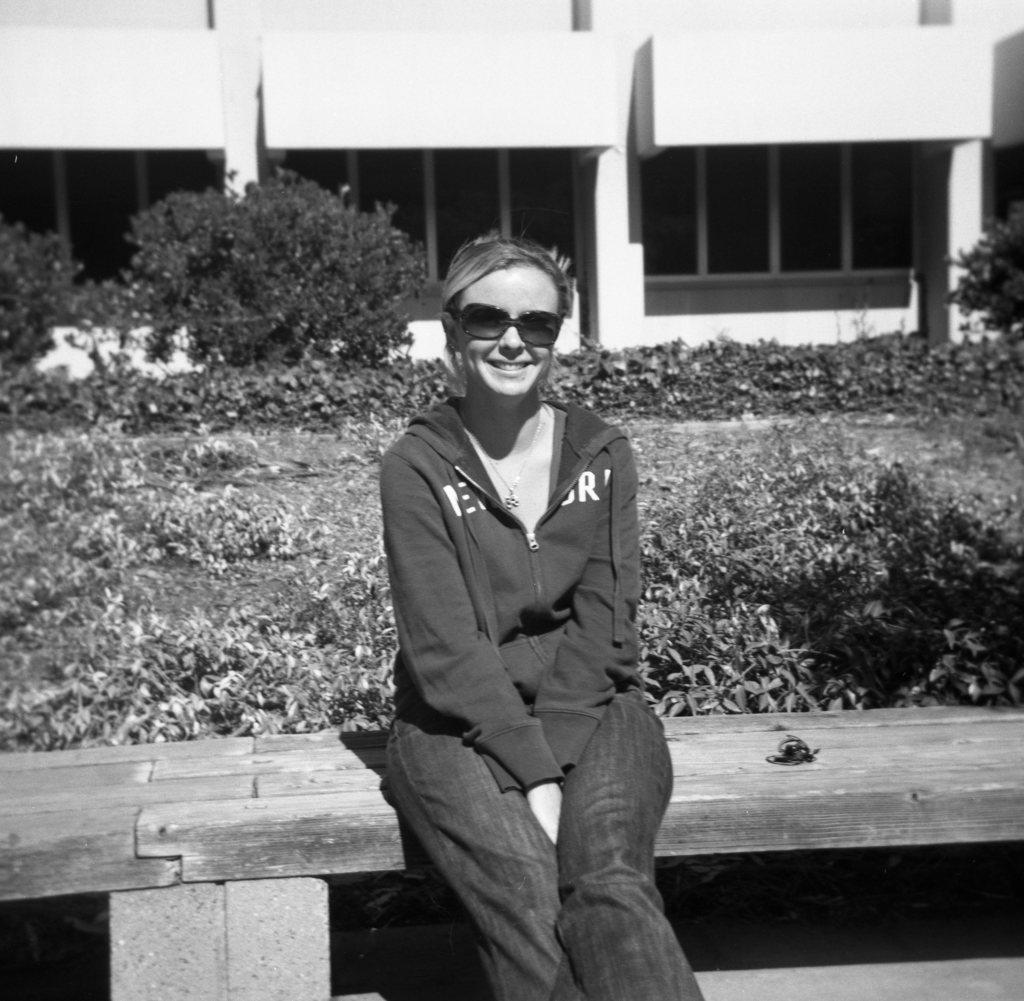What is the color scheme of the image? The image is black and white. What is the woman in the image doing? The woman is sitting on a bench in the image. What is the woman's expression in the image? The woman is smiling in the image. What can be seen in the background of the image? There are planets and a building visible in the background of the image. Is the woman saying good-bye to the ghost in the image? There is no ghost present in the image, and the woman's actions do not suggest that she is saying good-bye to anyone. 